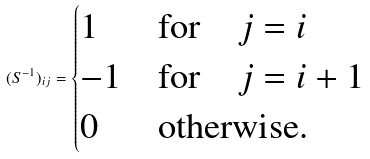Convert formula to latex. <formula><loc_0><loc_0><loc_500><loc_500>( S ^ { - 1 } ) _ { i j } = \begin{cases} 1 & \text {for} \quad j = i \\ - 1 & \text {for} \quad j = i + 1 \\ 0 & \text {otherwise.} \end{cases}</formula> 